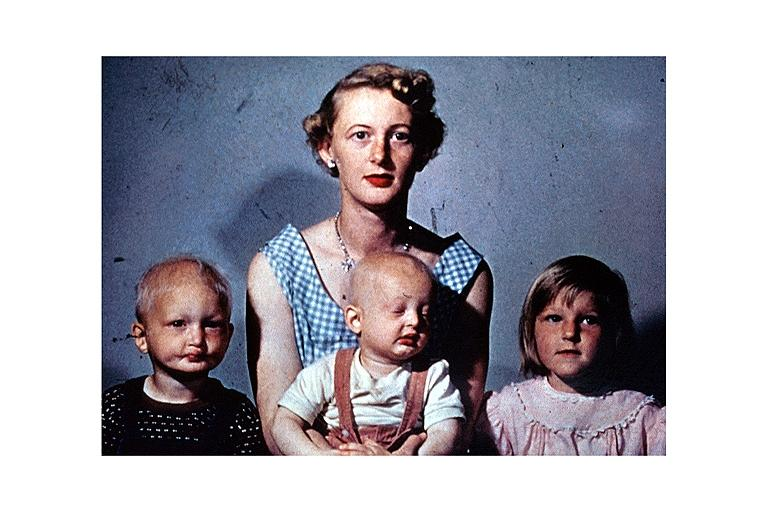s oral present?
Answer the question using a single word or phrase. Yes 